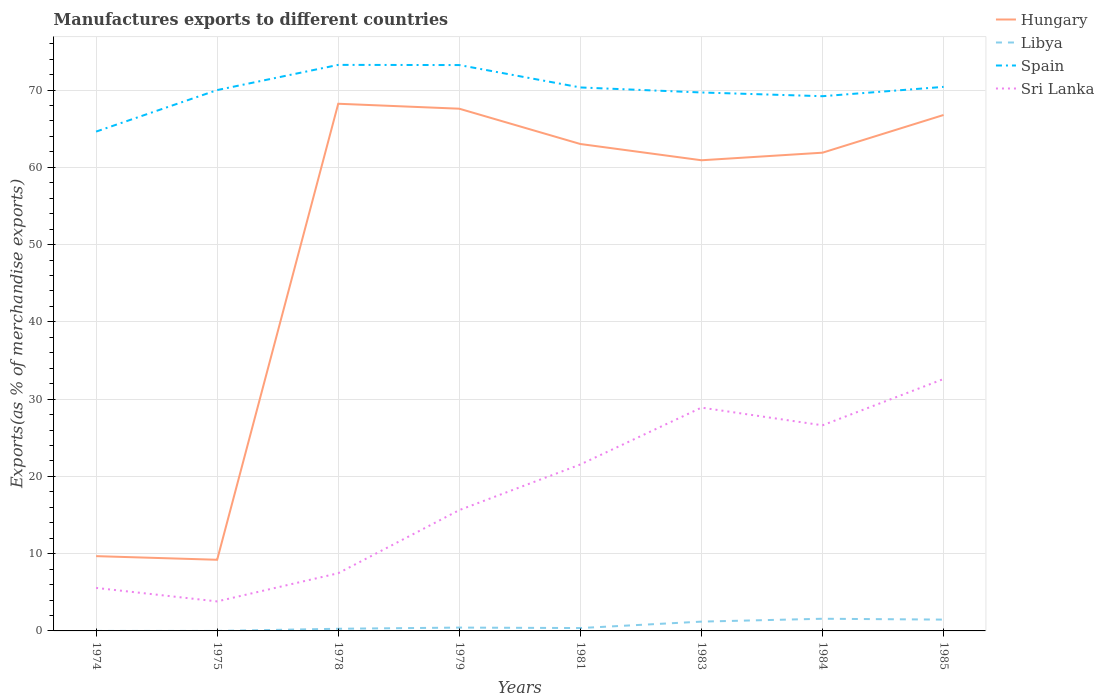How many different coloured lines are there?
Ensure brevity in your answer.  4. Does the line corresponding to Hungary intersect with the line corresponding to Spain?
Your answer should be compact. No. Across all years, what is the maximum percentage of exports to different countries in Spain?
Provide a succinct answer. 64.62. In which year was the percentage of exports to different countries in Hungary maximum?
Give a very brief answer. 1975. What is the total percentage of exports to different countries in Sri Lanka in the graph?
Offer a very short reply. -16.97. What is the difference between the highest and the second highest percentage of exports to different countries in Spain?
Keep it short and to the point. 8.64. Is the percentage of exports to different countries in Libya strictly greater than the percentage of exports to different countries in Hungary over the years?
Your answer should be compact. Yes. What is the difference between two consecutive major ticks on the Y-axis?
Make the answer very short. 10. Does the graph contain grids?
Make the answer very short. Yes. How are the legend labels stacked?
Keep it short and to the point. Vertical. What is the title of the graph?
Provide a succinct answer. Manufactures exports to different countries. What is the label or title of the X-axis?
Your response must be concise. Years. What is the label or title of the Y-axis?
Your response must be concise. Exports(as % of merchandise exports). What is the Exports(as % of merchandise exports) in Hungary in 1974?
Your response must be concise. 9.68. What is the Exports(as % of merchandise exports) of Libya in 1974?
Ensure brevity in your answer.  3.148296593577001e-5. What is the Exports(as % of merchandise exports) of Spain in 1974?
Your response must be concise. 64.62. What is the Exports(as % of merchandise exports) in Sri Lanka in 1974?
Your answer should be very brief. 5.57. What is the Exports(as % of merchandise exports) in Hungary in 1975?
Offer a very short reply. 9.21. What is the Exports(as % of merchandise exports) of Libya in 1975?
Provide a short and direct response. 9.803995570574699e-7. What is the Exports(as % of merchandise exports) of Spain in 1975?
Ensure brevity in your answer.  70. What is the Exports(as % of merchandise exports) of Sri Lanka in 1975?
Keep it short and to the point. 3.82. What is the Exports(as % of merchandise exports) of Hungary in 1978?
Make the answer very short. 68.23. What is the Exports(as % of merchandise exports) of Libya in 1978?
Offer a terse response. 0.28. What is the Exports(as % of merchandise exports) in Spain in 1978?
Offer a terse response. 73.26. What is the Exports(as % of merchandise exports) in Sri Lanka in 1978?
Make the answer very short. 7.47. What is the Exports(as % of merchandise exports) of Hungary in 1979?
Make the answer very short. 67.59. What is the Exports(as % of merchandise exports) in Libya in 1979?
Offer a terse response. 0.43. What is the Exports(as % of merchandise exports) in Spain in 1979?
Offer a terse response. 73.23. What is the Exports(as % of merchandise exports) of Sri Lanka in 1979?
Your answer should be very brief. 15.64. What is the Exports(as % of merchandise exports) of Hungary in 1981?
Provide a succinct answer. 63.02. What is the Exports(as % of merchandise exports) of Libya in 1981?
Offer a terse response. 0.37. What is the Exports(as % of merchandise exports) of Spain in 1981?
Your response must be concise. 70.34. What is the Exports(as % of merchandise exports) in Sri Lanka in 1981?
Make the answer very short. 21.54. What is the Exports(as % of merchandise exports) in Hungary in 1983?
Your response must be concise. 60.91. What is the Exports(as % of merchandise exports) in Libya in 1983?
Give a very brief answer. 1.2. What is the Exports(as % of merchandise exports) in Spain in 1983?
Make the answer very short. 69.69. What is the Exports(as % of merchandise exports) of Sri Lanka in 1983?
Give a very brief answer. 28.9. What is the Exports(as % of merchandise exports) of Hungary in 1984?
Give a very brief answer. 61.89. What is the Exports(as % of merchandise exports) in Libya in 1984?
Make the answer very short. 1.58. What is the Exports(as % of merchandise exports) of Spain in 1984?
Give a very brief answer. 69.2. What is the Exports(as % of merchandise exports) in Sri Lanka in 1984?
Provide a short and direct response. 26.61. What is the Exports(as % of merchandise exports) in Hungary in 1985?
Offer a terse response. 66.77. What is the Exports(as % of merchandise exports) of Libya in 1985?
Provide a succinct answer. 1.46. What is the Exports(as % of merchandise exports) of Spain in 1985?
Make the answer very short. 70.41. What is the Exports(as % of merchandise exports) of Sri Lanka in 1985?
Keep it short and to the point. 32.6. Across all years, what is the maximum Exports(as % of merchandise exports) in Hungary?
Provide a succinct answer. 68.23. Across all years, what is the maximum Exports(as % of merchandise exports) in Libya?
Offer a terse response. 1.58. Across all years, what is the maximum Exports(as % of merchandise exports) of Spain?
Provide a short and direct response. 73.26. Across all years, what is the maximum Exports(as % of merchandise exports) in Sri Lanka?
Provide a succinct answer. 32.6. Across all years, what is the minimum Exports(as % of merchandise exports) in Hungary?
Offer a very short reply. 9.21. Across all years, what is the minimum Exports(as % of merchandise exports) in Libya?
Give a very brief answer. 9.803995570574699e-7. Across all years, what is the minimum Exports(as % of merchandise exports) in Spain?
Offer a very short reply. 64.62. Across all years, what is the minimum Exports(as % of merchandise exports) of Sri Lanka?
Your answer should be compact. 3.82. What is the total Exports(as % of merchandise exports) in Hungary in the graph?
Give a very brief answer. 407.3. What is the total Exports(as % of merchandise exports) in Libya in the graph?
Offer a very short reply. 5.33. What is the total Exports(as % of merchandise exports) in Spain in the graph?
Provide a short and direct response. 560.75. What is the total Exports(as % of merchandise exports) of Sri Lanka in the graph?
Your answer should be very brief. 142.15. What is the difference between the Exports(as % of merchandise exports) in Hungary in 1974 and that in 1975?
Offer a terse response. 0.47. What is the difference between the Exports(as % of merchandise exports) of Libya in 1974 and that in 1975?
Give a very brief answer. 0. What is the difference between the Exports(as % of merchandise exports) in Spain in 1974 and that in 1975?
Offer a very short reply. -5.37. What is the difference between the Exports(as % of merchandise exports) in Sri Lanka in 1974 and that in 1975?
Provide a short and direct response. 1.75. What is the difference between the Exports(as % of merchandise exports) of Hungary in 1974 and that in 1978?
Your answer should be very brief. -58.55. What is the difference between the Exports(as % of merchandise exports) in Libya in 1974 and that in 1978?
Make the answer very short. -0.28. What is the difference between the Exports(as % of merchandise exports) of Spain in 1974 and that in 1978?
Provide a succinct answer. -8.64. What is the difference between the Exports(as % of merchandise exports) of Hungary in 1974 and that in 1979?
Your answer should be very brief. -57.91. What is the difference between the Exports(as % of merchandise exports) in Libya in 1974 and that in 1979?
Provide a succinct answer. -0.43. What is the difference between the Exports(as % of merchandise exports) of Spain in 1974 and that in 1979?
Make the answer very short. -8.61. What is the difference between the Exports(as % of merchandise exports) of Sri Lanka in 1974 and that in 1979?
Provide a succinct answer. -10.07. What is the difference between the Exports(as % of merchandise exports) of Hungary in 1974 and that in 1981?
Keep it short and to the point. -53.34. What is the difference between the Exports(as % of merchandise exports) in Libya in 1974 and that in 1981?
Make the answer very short. -0.37. What is the difference between the Exports(as % of merchandise exports) of Spain in 1974 and that in 1981?
Offer a terse response. -5.71. What is the difference between the Exports(as % of merchandise exports) in Sri Lanka in 1974 and that in 1981?
Make the answer very short. -15.98. What is the difference between the Exports(as % of merchandise exports) of Hungary in 1974 and that in 1983?
Your answer should be very brief. -51.23. What is the difference between the Exports(as % of merchandise exports) in Libya in 1974 and that in 1983?
Make the answer very short. -1.2. What is the difference between the Exports(as % of merchandise exports) of Spain in 1974 and that in 1983?
Offer a terse response. -5.06. What is the difference between the Exports(as % of merchandise exports) in Sri Lanka in 1974 and that in 1983?
Give a very brief answer. -23.33. What is the difference between the Exports(as % of merchandise exports) in Hungary in 1974 and that in 1984?
Ensure brevity in your answer.  -52.22. What is the difference between the Exports(as % of merchandise exports) in Libya in 1974 and that in 1984?
Provide a short and direct response. -1.58. What is the difference between the Exports(as % of merchandise exports) in Spain in 1974 and that in 1984?
Your answer should be compact. -4.58. What is the difference between the Exports(as % of merchandise exports) in Sri Lanka in 1974 and that in 1984?
Ensure brevity in your answer.  -21.04. What is the difference between the Exports(as % of merchandise exports) in Hungary in 1974 and that in 1985?
Your answer should be very brief. -57.1. What is the difference between the Exports(as % of merchandise exports) in Libya in 1974 and that in 1985?
Your answer should be compact. -1.46. What is the difference between the Exports(as % of merchandise exports) of Spain in 1974 and that in 1985?
Offer a terse response. -5.79. What is the difference between the Exports(as % of merchandise exports) in Sri Lanka in 1974 and that in 1985?
Your answer should be compact. -27.04. What is the difference between the Exports(as % of merchandise exports) of Hungary in 1975 and that in 1978?
Give a very brief answer. -59.02. What is the difference between the Exports(as % of merchandise exports) of Libya in 1975 and that in 1978?
Give a very brief answer. -0.28. What is the difference between the Exports(as % of merchandise exports) of Spain in 1975 and that in 1978?
Keep it short and to the point. -3.26. What is the difference between the Exports(as % of merchandise exports) in Sri Lanka in 1975 and that in 1978?
Ensure brevity in your answer.  -3.65. What is the difference between the Exports(as % of merchandise exports) of Hungary in 1975 and that in 1979?
Make the answer very short. -58.38. What is the difference between the Exports(as % of merchandise exports) in Libya in 1975 and that in 1979?
Keep it short and to the point. -0.43. What is the difference between the Exports(as % of merchandise exports) of Spain in 1975 and that in 1979?
Ensure brevity in your answer.  -3.24. What is the difference between the Exports(as % of merchandise exports) of Sri Lanka in 1975 and that in 1979?
Your response must be concise. -11.82. What is the difference between the Exports(as % of merchandise exports) in Hungary in 1975 and that in 1981?
Ensure brevity in your answer.  -53.81. What is the difference between the Exports(as % of merchandise exports) in Libya in 1975 and that in 1981?
Your response must be concise. -0.37. What is the difference between the Exports(as % of merchandise exports) in Spain in 1975 and that in 1981?
Provide a short and direct response. -0.34. What is the difference between the Exports(as % of merchandise exports) of Sri Lanka in 1975 and that in 1981?
Offer a terse response. -17.72. What is the difference between the Exports(as % of merchandise exports) in Hungary in 1975 and that in 1983?
Provide a succinct answer. -51.7. What is the difference between the Exports(as % of merchandise exports) of Libya in 1975 and that in 1983?
Your answer should be compact. -1.2. What is the difference between the Exports(as % of merchandise exports) in Spain in 1975 and that in 1983?
Provide a short and direct response. 0.31. What is the difference between the Exports(as % of merchandise exports) of Sri Lanka in 1975 and that in 1983?
Ensure brevity in your answer.  -25.08. What is the difference between the Exports(as % of merchandise exports) of Hungary in 1975 and that in 1984?
Provide a succinct answer. -52.69. What is the difference between the Exports(as % of merchandise exports) of Libya in 1975 and that in 1984?
Make the answer very short. -1.58. What is the difference between the Exports(as % of merchandise exports) in Spain in 1975 and that in 1984?
Provide a short and direct response. 0.79. What is the difference between the Exports(as % of merchandise exports) in Sri Lanka in 1975 and that in 1984?
Provide a succinct answer. -22.79. What is the difference between the Exports(as % of merchandise exports) in Hungary in 1975 and that in 1985?
Give a very brief answer. -57.56. What is the difference between the Exports(as % of merchandise exports) of Libya in 1975 and that in 1985?
Make the answer very short. -1.46. What is the difference between the Exports(as % of merchandise exports) in Spain in 1975 and that in 1985?
Offer a very short reply. -0.41. What is the difference between the Exports(as % of merchandise exports) of Sri Lanka in 1975 and that in 1985?
Keep it short and to the point. -28.78. What is the difference between the Exports(as % of merchandise exports) of Hungary in 1978 and that in 1979?
Your answer should be compact. 0.64. What is the difference between the Exports(as % of merchandise exports) of Libya in 1978 and that in 1979?
Give a very brief answer. -0.15. What is the difference between the Exports(as % of merchandise exports) in Spain in 1978 and that in 1979?
Ensure brevity in your answer.  0.02. What is the difference between the Exports(as % of merchandise exports) in Sri Lanka in 1978 and that in 1979?
Ensure brevity in your answer.  -8.17. What is the difference between the Exports(as % of merchandise exports) in Hungary in 1978 and that in 1981?
Provide a succinct answer. 5.21. What is the difference between the Exports(as % of merchandise exports) in Libya in 1978 and that in 1981?
Your answer should be compact. -0.09. What is the difference between the Exports(as % of merchandise exports) of Spain in 1978 and that in 1981?
Give a very brief answer. 2.92. What is the difference between the Exports(as % of merchandise exports) of Sri Lanka in 1978 and that in 1981?
Make the answer very short. -14.08. What is the difference between the Exports(as % of merchandise exports) in Hungary in 1978 and that in 1983?
Offer a very short reply. 7.31. What is the difference between the Exports(as % of merchandise exports) in Libya in 1978 and that in 1983?
Provide a short and direct response. -0.92. What is the difference between the Exports(as % of merchandise exports) of Spain in 1978 and that in 1983?
Your answer should be very brief. 3.57. What is the difference between the Exports(as % of merchandise exports) in Sri Lanka in 1978 and that in 1983?
Offer a very short reply. -21.43. What is the difference between the Exports(as % of merchandise exports) of Hungary in 1978 and that in 1984?
Provide a short and direct response. 6.33. What is the difference between the Exports(as % of merchandise exports) in Libya in 1978 and that in 1984?
Keep it short and to the point. -1.3. What is the difference between the Exports(as % of merchandise exports) of Spain in 1978 and that in 1984?
Offer a very short reply. 4.05. What is the difference between the Exports(as % of merchandise exports) in Sri Lanka in 1978 and that in 1984?
Keep it short and to the point. -19.14. What is the difference between the Exports(as % of merchandise exports) of Hungary in 1978 and that in 1985?
Ensure brevity in your answer.  1.45. What is the difference between the Exports(as % of merchandise exports) of Libya in 1978 and that in 1985?
Make the answer very short. -1.19. What is the difference between the Exports(as % of merchandise exports) in Spain in 1978 and that in 1985?
Provide a short and direct response. 2.85. What is the difference between the Exports(as % of merchandise exports) in Sri Lanka in 1978 and that in 1985?
Your response must be concise. -25.14. What is the difference between the Exports(as % of merchandise exports) in Hungary in 1979 and that in 1981?
Offer a very short reply. 4.57. What is the difference between the Exports(as % of merchandise exports) of Libya in 1979 and that in 1981?
Offer a terse response. 0.06. What is the difference between the Exports(as % of merchandise exports) in Spain in 1979 and that in 1981?
Give a very brief answer. 2.9. What is the difference between the Exports(as % of merchandise exports) in Sri Lanka in 1979 and that in 1981?
Offer a very short reply. -5.9. What is the difference between the Exports(as % of merchandise exports) of Hungary in 1979 and that in 1983?
Offer a terse response. 6.67. What is the difference between the Exports(as % of merchandise exports) in Libya in 1979 and that in 1983?
Provide a succinct answer. -0.77. What is the difference between the Exports(as % of merchandise exports) of Spain in 1979 and that in 1983?
Give a very brief answer. 3.55. What is the difference between the Exports(as % of merchandise exports) in Sri Lanka in 1979 and that in 1983?
Offer a terse response. -13.26. What is the difference between the Exports(as % of merchandise exports) in Hungary in 1979 and that in 1984?
Keep it short and to the point. 5.69. What is the difference between the Exports(as % of merchandise exports) of Libya in 1979 and that in 1984?
Make the answer very short. -1.14. What is the difference between the Exports(as % of merchandise exports) of Spain in 1979 and that in 1984?
Give a very brief answer. 4.03. What is the difference between the Exports(as % of merchandise exports) of Sri Lanka in 1979 and that in 1984?
Make the answer very short. -10.97. What is the difference between the Exports(as % of merchandise exports) of Hungary in 1979 and that in 1985?
Provide a succinct answer. 0.81. What is the difference between the Exports(as % of merchandise exports) in Libya in 1979 and that in 1985?
Provide a succinct answer. -1.03. What is the difference between the Exports(as % of merchandise exports) of Spain in 1979 and that in 1985?
Your answer should be very brief. 2.82. What is the difference between the Exports(as % of merchandise exports) of Sri Lanka in 1979 and that in 1985?
Keep it short and to the point. -16.97. What is the difference between the Exports(as % of merchandise exports) in Hungary in 1981 and that in 1983?
Your answer should be compact. 2.1. What is the difference between the Exports(as % of merchandise exports) in Libya in 1981 and that in 1983?
Provide a short and direct response. -0.83. What is the difference between the Exports(as % of merchandise exports) of Spain in 1981 and that in 1983?
Ensure brevity in your answer.  0.65. What is the difference between the Exports(as % of merchandise exports) of Sri Lanka in 1981 and that in 1983?
Your answer should be very brief. -7.36. What is the difference between the Exports(as % of merchandise exports) of Hungary in 1981 and that in 1984?
Give a very brief answer. 1.12. What is the difference between the Exports(as % of merchandise exports) in Libya in 1981 and that in 1984?
Ensure brevity in your answer.  -1.2. What is the difference between the Exports(as % of merchandise exports) in Spain in 1981 and that in 1984?
Provide a succinct answer. 1.13. What is the difference between the Exports(as % of merchandise exports) in Sri Lanka in 1981 and that in 1984?
Your response must be concise. -5.07. What is the difference between the Exports(as % of merchandise exports) of Hungary in 1981 and that in 1985?
Offer a terse response. -3.76. What is the difference between the Exports(as % of merchandise exports) in Libya in 1981 and that in 1985?
Keep it short and to the point. -1.09. What is the difference between the Exports(as % of merchandise exports) in Spain in 1981 and that in 1985?
Offer a very short reply. -0.07. What is the difference between the Exports(as % of merchandise exports) of Sri Lanka in 1981 and that in 1985?
Offer a terse response. -11.06. What is the difference between the Exports(as % of merchandise exports) of Hungary in 1983 and that in 1984?
Ensure brevity in your answer.  -0.98. What is the difference between the Exports(as % of merchandise exports) in Libya in 1983 and that in 1984?
Your answer should be compact. -0.37. What is the difference between the Exports(as % of merchandise exports) of Spain in 1983 and that in 1984?
Offer a terse response. 0.48. What is the difference between the Exports(as % of merchandise exports) of Sri Lanka in 1983 and that in 1984?
Your answer should be very brief. 2.29. What is the difference between the Exports(as % of merchandise exports) in Hungary in 1983 and that in 1985?
Offer a very short reply. -5.86. What is the difference between the Exports(as % of merchandise exports) in Libya in 1983 and that in 1985?
Provide a short and direct response. -0.26. What is the difference between the Exports(as % of merchandise exports) of Spain in 1983 and that in 1985?
Your answer should be very brief. -0.72. What is the difference between the Exports(as % of merchandise exports) of Sri Lanka in 1983 and that in 1985?
Your answer should be compact. -3.7. What is the difference between the Exports(as % of merchandise exports) of Hungary in 1984 and that in 1985?
Keep it short and to the point. -4.88. What is the difference between the Exports(as % of merchandise exports) of Libya in 1984 and that in 1985?
Give a very brief answer. 0.11. What is the difference between the Exports(as % of merchandise exports) in Spain in 1984 and that in 1985?
Offer a terse response. -1.21. What is the difference between the Exports(as % of merchandise exports) in Sri Lanka in 1984 and that in 1985?
Ensure brevity in your answer.  -5.99. What is the difference between the Exports(as % of merchandise exports) in Hungary in 1974 and the Exports(as % of merchandise exports) in Libya in 1975?
Your response must be concise. 9.68. What is the difference between the Exports(as % of merchandise exports) of Hungary in 1974 and the Exports(as % of merchandise exports) of Spain in 1975?
Provide a short and direct response. -60.32. What is the difference between the Exports(as % of merchandise exports) in Hungary in 1974 and the Exports(as % of merchandise exports) in Sri Lanka in 1975?
Keep it short and to the point. 5.86. What is the difference between the Exports(as % of merchandise exports) of Libya in 1974 and the Exports(as % of merchandise exports) of Spain in 1975?
Make the answer very short. -70. What is the difference between the Exports(as % of merchandise exports) of Libya in 1974 and the Exports(as % of merchandise exports) of Sri Lanka in 1975?
Offer a terse response. -3.82. What is the difference between the Exports(as % of merchandise exports) of Spain in 1974 and the Exports(as % of merchandise exports) of Sri Lanka in 1975?
Offer a very short reply. 60.8. What is the difference between the Exports(as % of merchandise exports) of Hungary in 1974 and the Exports(as % of merchandise exports) of Libya in 1978?
Offer a very short reply. 9.4. What is the difference between the Exports(as % of merchandise exports) of Hungary in 1974 and the Exports(as % of merchandise exports) of Spain in 1978?
Offer a very short reply. -63.58. What is the difference between the Exports(as % of merchandise exports) in Hungary in 1974 and the Exports(as % of merchandise exports) in Sri Lanka in 1978?
Provide a short and direct response. 2.21. What is the difference between the Exports(as % of merchandise exports) of Libya in 1974 and the Exports(as % of merchandise exports) of Spain in 1978?
Your answer should be compact. -73.26. What is the difference between the Exports(as % of merchandise exports) of Libya in 1974 and the Exports(as % of merchandise exports) of Sri Lanka in 1978?
Offer a very short reply. -7.47. What is the difference between the Exports(as % of merchandise exports) of Spain in 1974 and the Exports(as % of merchandise exports) of Sri Lanka in 1978?
Make the answer very short. 57.16. What is the difference between the Exports(as % of merchandise exports) of Hungary in 1974 and the Exports(as % of merchandise exports) of Libya in 1979?
Keep it short and to the point. 9.25. What is the difference between the Exports(as % of merchandise exports) of Hungary in 1974 and the Exports(as % of merchandise exports) of Spain in 1979?
Give a very brief answer. -63.56. What is the difference between the Exports(as % of merchandise exports) of Hungary in 1974 and the Exports(as % of merchandise exports) of Sri Lanka in 1979?
Keep it short and to the point. -5.96. What is the difference between the Exports(as % of merchandise exports) in Libya in 1974 and the Exports(as % of merchandise exports) in Spain in 1979?
Your response must be concise. -73.23. What is the difference between the Exports(as % of merchandise exports) of Libya in 1974 and the Exports(as % of merchandise exports) of Sri Lanka in 1979?
Ensure brevity in your answer.  -15.64. What is the difference between the Exports(as % of merchandise exports) of Spain in 1974 and the Exports(as % of merchandise exports) of Sri Lanka in 1979?
Offer a terse response. 48.98. What is the difference between the Exports(as % of merchandise exports) in Hungary in 1974 and the Exports(as % of merchandise exports) in Libya in 1981?
Offer a very short reply. 9.31. What is the difference between the Exports(as % of merchandise exports) of Hungary in 1974 and the Exports(as % of merchandise exports) of Spain in 1981?
Ensure brevity in your answer.  -60.66. What is the difference between the Exports(as % of merchandise exports) in Hungary in 1974 and the Exports(as % of merchandise exports) in Sri Lanka in 1981?
Your answer should be compact. -11.86. What is the difference between the Exports(as % of merchandise exports) of Libya in 1974 and the Exports(as % of merchandise exports) of Spain in 1981?
Your answer should be very brief. -70.34. What is the difference between the Exports(as % of merchandise exports) of Libya in 1974 and the Exports(as % of merchandise exports) of Sri Lanka in 1981?
Your answer should be compact. -21.54. What is the difference between the Exports(as % of merchandise exports) of Spain in 1974 and the Exports(as % of merchandise exports) of Sri Lanka in 1981?
Keep it short and to the point. 43.08. What is the difference between the Exports(as % of merchandise exports) of Hungary in 1974 and the Exports(as % of merchandise exports) of Libya in 1983?
Provide a succinct answer. 8.48. What is the difference between the Exports(as % of merchandise exports) in Hungary in 1974 and the Exports(as % of merchandise exports) in Spain in 1983?
Provide a succinct answer. -60.01. What is the difference between the Exports(as % of merchandise exports) of Hungary in 1974 and the Exports(as % of merchandise exports) of Sri Lanka in 1983?
Your answer should be compact. -19.22. What is the difference between the Exports(as % of merchandise exports) of Libya in 1974 and the Exports(as % of merchandise exports) of Spain in 1983?
Ensure brevity in your answer.  -69.69. What is the difference between the Exports(as % of merchandise exports) in Libya in 1974 and the Exports(as % of merchandise exports) in Sri Lanka in 1983?
Give a very brief answer. -28.9. What is the difference between the Exports(as % of merchandise exports) of Spain in 1974 and the Exports(as % of merchandise exports) of Sri Lanka in 1983?
Offer a terse response. 35.72. What is the difference between the Exports(as % of merchandise exports) in Hungary in 1974 and the Exports(as % of merchandise exports) in Libya in 1984?
Keep it short and to the point. 8.1. What is the difference between the Exports(as % of merchandise exports) of Hungary in 1974 and the Exports(as % of merchandise exports) of Spain in 1984?
Offer a terse response. -59.53. What is the difference between the Exports(as % of merchandise exports) in Hungary in 1974 and the Exports(as % of merchandise exports) in Sri Lanka in 1984?
Provide a succinct answer. -16.93. What is the difference between the Exports(as % of merchandise exports) in Libya in 1974 and the Exports(as % of merchandise exports) in Spain in 1984?
Offer a very short reply. -69.2. What is the difference between the Exports(as % of merchandise exports) in Libya in 1974 and the Exports(as % of merchandise exports) in Sri Lanka in 1984?
Your response must be concise. -26.61. What is the difference between the Exports(as % of merchandise exports) of Spain in 1974 and the Exports(as % of merchandise exports) of Sri Lanka in 1984?
Give a very brief answer. 38.01. What is the difference between the Exports(as % of merchandise exports) in Hungary in 1974 and the Exports(as % of merchandise exports) in Libya in 1985?
Provide a short and direct response. 8.21. What is the difference between the Exports(as % of merchandise exports) of Hungary in 1974 and the Exports(as % of merchandise exports) of Spain in 1985?
Offer a terse response. -60.73. What is the difference between the Exports(as % of merchandise exports) of Hungary in 1974 and the Exports(as % of merchandise exports) of Sri Lanka in 1985?
Your response must be concise. -22.93. What is the difference between the Exports(as % of merchandise exports) in Libya in 1974 and the Exports(as % of merchandise exports) in Spain in 1985?
Your response must be concise. -70.41. What is the difference between the Exports(as % of merchandise exports) in Libya in 1974 and the Exports(as % of merchandise exports) in Sri Lanka in 1985?
Keep it short and to the point. -32.6. What is the difference between the Exports(as % of merchandise exports) in Spain in 1974 and the Exports(as % of merchandise exports) in Sri Lanka in 1985?
Keep it short and to the point. 32.02. What is the difference between the Exports(as % of merchandise exports) in Hungary in 1975 and the Exports(as % of merchandise exports) in Libya in 1978?
Offer a very short reply. 8.93. What is the difference between the Exports(as % of merchandise exports) of Hungary in 1975 and the Exports(as % of merchandise exports) of Spain in 1978?
Give a very brief answer. -64.05. What is the difference between the Exports(as % of merchandise exports) in Hungary in 1975 and the Exports(as % of merchandise exports) in Sri Lanka in 1978?
Offer a very short reply. 1.74. What is the difference between the Exports(as % of merchandise exports) of Libya in 1975 and the Exports(as % of merchandise exports) of Spain in 1978?
Your response must be concise. -73.26. What is the difference between the Exports(as % of merchandise exports) in Libya in 1975 and the Exports(as % of merchandise exports) in Sri Lanka in 1978?
Your answer should be compact. -7.47. What is the difference between the Exports(as % of merchandise exports) in Spain in 1975 and the Exports(as % of merchandise exports) in Sri Lanka in 1978?
Provide a short and direct response. 62.53. What is the difference between the Exports(as % of merchandise exports) of Hungary in 1975 and the Exports(as % of merchandise exports) of Libya in 1979?
Ensure brevity in your answer.  8.78. What is the difference between the Exports(as % of merchandise exports) in Hungary in 1975 and the Exports(as % of merchandise exports) in Spain in 1979?
Your answer should be very brief. -64.03. What is the difference between the Exports(as % of merchandise exports) of Hungary in 1975 and the Exports(as % of merchandise exports) of Sri Lanka in 1979?
Provide a short and direct response. -6.43. What is the difference between the Exports(as % of merchandise exports) in Libya in 1975 and the Exports(as % of merchandise exports) in Spain in 1979?
Your response must be concise. -73.23. What is the difference between the Exports(as % of merchandise exports) in Libya in 1975 and the Exports(as % of merchandise exports) in Sri Lanka in 1979?
Offer a very short reply. -15.64. What is the difference between the Exports(as % of merchandise exports) of Spain in 1975 and the Exports(as % of merchandise exports) of Sri Lanka in 1979?
Give a very brief answer. 54.36. What is the difference between the Exports(as % of merchandise exports) in Hungary in 1975 and the Exports(as % of merchandise exports) in Libya in 1981?
Ensure brevity in your answer.  8.84. What is the difference between the Exports(as % of merchandise exports) of Hungary in 1975 and the Exports(as % of merchandise exports) of Spain in 1981?
Provide a short and direct response. -61.13. What is the difference between the Exports(as % of merchandise exports) of Hungary in 1975 and the Exports(as % of merchandise exports) of Sri Lanka in 1981?
Your answer should be compact. -12.33. What is the difference between the Exports(as % of merchandise exports) in Libya in 1975 and the Exports(as % of merchandise exports) in Spain in 1981?
Your answer should be compact. -70.34. What is the difference between the Exports(as % of merchandise exports) of Libya in 1975 and the Exports(as % of merchandise exports) of Sri Lanka in 1981?
Keep it short and to the point. -21.54. What is the difference between the Exports(as % of merchandise exports) of Spain in 1975 and the Exports(as % of merchandise exports) of Sri Lanka in 1981?
Make the answer very short. 48.45. What is the difference between the Exports(as % of merchandise exports) in Hungary in 1975 and the Exports(as % of merchandise exports) in Libya in 1983?
Your response must be concise. 8.01. What is the difference between the Exports(as % of merchandise exports) in Hungary in 1975 and the Exports(as % of merchandise exports) in Spain in 1983?
Give a very brief answer. -60.48. What is the difference between the Exports(as % of merchandise exports) of Hungary in 1975 and the Exports(as % of merchandise exports) of Sri Lanka in 1983?
Provide a short and direct response. -19.69. What is the difference between the Exports(as % of merchandise exports) in Libya in 1975 and the Exports(as % of merchandise exports) in Spain in 1983?
Ensure brevity in your answer.  -69.69. What is the difference between the Exports(as % of merchandise exports) of Libya in 1975 and the Exports(as % of merchandise exports) of Sri Lanka in 1983?
Provide a short and direct response. -28.9. What is the difference between the Exports(as % of merchandise exports) in Spain in 1975 and the Exports(as % of merchandise exports) in Sri Lanka in 1983?
Your answer should be compact. 41.1. What is the difference between the Exports(as % of merchandise exports) in Hungary in 1975 and the Exports(as % of merchandise exports) in Libya in 1984?
Ensure brevity in your answer.  7.63. What is the difference between the Exports(as % of merchandise exports) of Hungary in 1975 and the Exports(as % of merchandise exports) of Spain in 1984?
Offer a very short reply. -60. What is the difference between the Exports(as % of merchandise exports) of Hungary in 1975 and the Exports(as % of merchandise exports) of Sri Lanka in 1984?
Your answer should be compact. -17.4. What is the difference between the Exports(as % of merchandise exports) of Libya in 1975 and the Exports(as % of merchandise exports) of Spain in 1984?
Your response must be concise. -69.2. What is the difference between the Exports(as % of merchandise exports) in Libya in 1975 and the Exports(as % of merchandise exports) in Sri Lanka in 1984?
Offer a very short reply. -26.61. What is the difference between the Exports(as % of merchandise exports) in Spain in 1975 and the Exports(as % of merchandise exports) in Sri Lanka in 1984?
Provide a succinct answer. 43.38. What is the difference between the Exports(as % of merchandise exports) in Hungary in 1975 and the Exports(as % of merchandise exports) in Libya in 1985?
Provide a short and direct response. 7.74. What is the difference between the Exports(as % of merchandise exports) of Hungary in 1975 and the Exports(as % of merchandise exports) of Spain in 1985?
Your response must be concise. -61.2. What is the difference between the Exports(as % of merchandise exports) of Hungary in 1975 and the Exports(as % of merchandise exports) of Sri Lanka in 1985?
Your answer should be very brief. -23.4. What is the difference between the Exports(as % of merchandise exports) in Libya in 1975 and the Exports(as % of merchandise exports) in Spain in 1985?
Offer a terse response. -70.41. What is the difference between the Exports(as % of merchandise exports) of Libya in 1975 and the Exports(as % of merchandise exports) of Sri Lanka in 1985?
Your response must be concise. -32.6. What is the difference between the Exports(as % of merchandise exports) of Spain in 1975 and the Exports(as % of merchandise exports) of Sri Lanka in 1985?
Your answer should be very brief. 37.39. What is the difference between the Exports(as % of merchandise exports) of Hungary in 1978 and the Exports(as % of merchandise exports) of Libya in 1979?
Ensure brevity in your answer.  67.8. What is the difference between the Exports(as % of merchandise exports) of Hungary in 1978 and the Exports(as % of merchandise exports) of Spain in 1979?
Your answer should be very brief. -5.01. What is the difference between the Exports(as % of merchandise exports) of Hungary in 1978 and the Exports(as % of merchandise exports) of Sri Lanka in 1979?
Offer a very short reply. 52.59. What is the difference between the Exports(as % of merchandise exports) in Libya in 1978 and the Exports(as % of merchandise exports) in Spain in 1979?
Make the answer very short. -72.95. What is the difference between the Exports(as % of merchandise exports) in Libya in 1978 and the Exports(as % of merchandise exports) in Sri Lanka in 1979?
Provide a short and direct response. -15.36. What is the difference between the Exports(as % of merchandise exports) in Spain in 1978 and the Exports(as % of merchandise exports) in Sri Lanka in 1979?
Your answer should be compact. 57.62. What is the difference between the Exports(as % of merchandise exports) of Hungary in 1978 and the Exports(as % of merchandise exports) of Libya in 1981?
Offer a terse response. 67.86. What is the difference between the Exports(as % of merchandise exports) in Hungary in 1978 and the Exports(as % of merchandise exports) in Spain in 1981?
Give a very brief answer. -2.11. What is the difference between the Exports(as % of merchandise exports) in Hungary in 1978 and the Exports(as % of merchandise exports) in Sri Lanka in 1981?
Keep it short and to the point. 46.69. What is the difference between the Exports(as % of merchandise exports) in Libya in 1978 and the Exports(as % of merchandise exports) in Spain in 1981?
Your response must be concise. -70.06. What is the difference between the Exports(as % of merchandise exports) of Libya in 1978 and the Exports(as % of merchandise exports) of Sri Lanka in 1981?
Keep it short and to the point. -21.26. What is the difference between the Exports(as % of merchandise exports) of Spain in 1978 and the Exports(as % of merchandise exports) of Sri Lanka in 1981?
Provide a short and direct response. 51.72. What is the difference between the Exports(as % of merchandise exports) in Hungary in 1978 and the Exports(as % of merchandise exports) in Libya in 1983?
Give a very brief answer. 67.02. What is the difference between the Exports(as % of merchandise exports) of Hungary in 1978 and the Exports(as % of merchandise exports) of Spain in 1983?
Make the answer very short. -1.46. What is the difference between the Exports(as % of merchandise exports) in Hungary in 1978 and the Exports(as % of merchandise exports) in Sri Lanka in 1983?
Ensure brevity in your answer.  39.33. What is the difference between the Exports(as % of merchandise exports) in Libya in 1978 and the Exports(as % of merchandise exports) in Spain in 1983?
Your response must be concise. -69.41. What is the difference between the Exports(as % of merchandise exports) in Libya in 1978 and the Exports(as % of merchandise exports) in Sri Lanka in 1983?
Provide a short and direct response. -28.62. What is the difference between the Exports(as % of merchandise exports) of Spain in 1978 and the Exports(as % of merchandise exports) of Sri Lanka in 1983?
Offer a terse response. 44.36. What is the difference between the Exports(as % of merchandise exports) in Hungary in 1978 and the Exports(as % of merchandise exports) in Libya in 1984?
Provide a succinct answer. 66.65. What is the difference between the Exports(as % of merchandise exports) in Hungary in 1978 and the Exports(as % of merchandise exports) in Spain in 1984?
Make the answer very short. -0.98. What is the difference between the Exports(as % of merchandise exports) in Hungary in 1978 and the Exports(as % of merchandise exports) in Sri Lanka in 1984?
Ensure brevity in your answer.  41.62. What is the difference between the Exports(as % of merchandise exports) of Libya in 1978 and the Exports(as % of merchandise exports) of Spain in 1984?
Your answer should be very brief. -68.92. What is the difference between the Exports(as % of merchandise exports) in Libya in 1978 and the Exports(as % of merchandise exports) in Sri Lanka in 1984?
Provide a short and direct response. -26.33. What is the difference between the Exports(as % of merchandise exports) in Spain in 1978 and the Exports(as % of merchandise exports) in Sri Lanka in 1984?
Provide a short and direct response. 46.65. What is the difference between the Exports(as % of merchandise exports) in Hungary in 1978 and the Exports(as % of merchandise exports) in Libya in 1985?
Offer a very short reply. 66.76. What is the difference between the Exports(as % of merchandise exports) in Hungary in 1978 and the Exports(as % of merchandise exports) in Spain in 1985?
Give a very brief answer. -2.18. What is the difference between the Exports(as % of merchandise exports) in Hungary in 1978 and the Exports(as % of merchandise exports) in Sri Lanka in 1985?
Provide a short and direct response. 35.62. What is the difference between the Exports(as % of merchandise exports) in Libya in 1978 and the Exports(as % of merchandise exports) in Spain in 1985?
Ensure brevity in your answer.  -70.13. What is the difference between the Exports(as % of merchandise exports) in Libya in 1978 and the Exports(as % of merchandise exports) in Sri Lanka in 1985?
Your response must be concise. -32.32. What is the difference between the Exports(as % of merchandise exports) in Spain in 1978 and the Exports(as % of merchandise exports) in Sri Lanka in 1985?
Provide a short and direct response. 40.65. What is the difference between the Exports(as % of merchandise exports) in Hungary in 1979 and the Exports(as % of merchandise exports) in Libya in 1981?
Keep it short and to the point. 67.21. What is the difference between the Exports(as % of merchandise exports) of Hungary in 1979 and the Exports(as % of merchandise exports) of Spain in 1981?
Your answer should be compact. -2.75. What is the difference between the Exports(as % of merchandise exports) of Hungary in 1979 and the Exports(as % of merchandise exports) of Sri Lanka in 1981?
Your answer should be compact. 46.04. What is the difference between the Exports(as % of merchandise exports) in Libya in 1979 and the Exports(as % of merchandise exports) in Spain in 1981?
Give a very brief answer. -69.9. What is the difference between the Exports(as % of merchandise exports) of Libya in 1979 and the Exports(as % of merchandise exports) of Sri Lanka in 1981?
Make the answer very short. -21.11. What is the difference between the Exports(as % of merchandise exports) in Spain in 1979 and the Exports(as % of merchandise exports) in Sri Lanka in 1981?
Offer a very short reply. 51.69. What is the difference between the Exports(as % of merchandise exports) of Hungary in 1979 and the Exports(as % of merchandise exports) of Libya in 1983?
Make the answer very short. 66.38. What is the difference between the Exports(as % of merchandise exports) in Hungary in 1979 and the Exports(as % of merchandise exports) in Spain in 1983?
Offer a terse response. -2.1. What is the difference between the Exports(as % of merchandise exports) in Hungary in 1979 and the Exports(as % of merchandise exports) in Sri Lanka in 1983?
Make the answer very short. 38.69. What is the difference between the Exports(as % of merchandise exports) in Libya in 1979 and the Exports(as % of merchandise exports) in Spain in 1983?
Your answer should be compact. -69.26. What is the difference between the Exports(as % of merchandise exports) of Libya in 1979 and the Exports(as % of merchandise exports) of Sri Lanka in 1983?
Give a very brief answer. -28.47. What is the difference between the Exports(as % of merchandise exports) of Spain in 1979 and the Exports(as % of merchandise exports) of Sri Lanka in 1983?
Keep it short and to the point. 44.33. What is the difference between the Exports(as % of merchandise exports) in Hungary in 1979 and the Exports(as % of merchandise exports) in Libya in 1984?
Offer a terse response. 66.01. What is the difference between the Exports(as % of merchandise exports) of Hungary in 1979 and the Exports(as % of merchandise exports) of Spain in 1984?
Provide a succinct answer. -1.62. What is the difference between the Exports(as % of merchandise exports) of Hungary in 1979 and the Exports(as % of merchandise exports) of Sri Lanka in 1984?
Give a very brief answer. 40.97. What is the difference between the Exports(as % of merchandise exports) in Libya in 1979 and the Exports(as % of merchandise exports) in Spain in 1984?
Offer a terse response. -68.77. What is the difference between the Exports(as % of merchandise exports) in Libya in 1979 and the Exports(as % of merchandise exports) in Sri Lanka in 1984?
Offer a terse response. -26.18. What is the difference between the Exports(as % of merchandise exports) of Spain in 1979 and the Exports(as % of merchandise exports) of Sri Lanka in 1984?
Your response must be concise. 46.62. What is the difference between the Exports(as % of merchandise exports) of Hungary in 1979 and the Exports(as % of merchandise exports) of Libya in 1985?
Make the answer very short. 66.12. What is the difference between the Exports(as % of merchandise exports) of Hungary in 1979 and the Exports(as % of merchandise exports) of Spain in 1985?
Provide a succinct answer. -2.83. What is the difference between the Exports(as % of merchandise exports) in Hungary in 1979 and the Exports(as % of merchandise exports) in Sri Lanka in 1985?
Your response must be concise. 34.98. What is the difference between the Exports(as % of merchandise exports) in Libya in 1979 and the Exports(as % of merchandise exports) in Spain in 1985?
Ensure brevity in your answer.  -69.98. What is the difference between the Exports(as % of merchandise exports) in Libya in 1979 and the Exports(as % of merchandise exports) in Sri Lanka in 1985?
Your response must be concise. -32.17. What is the difference between the Exports(as % of merchandise exports) in Spain in 1979 and the Exports(as % of merchandise exports) in Sri Lanka in 1985?
Make the answer very short. 40.63. What is the difference between the Exports(as % of merchandise exports) in Hungary in 1981 and the Exports(as % of merchandise exports) in Libya in 1983?
Keep it short and to the point. 61.81. What is the difference between the Exports(as % of merchandise exports) in Hungary in 1981 and the Exports(as % of merchandise exports) in Spain in 1983?
Offer a very short reply. -6.67. What is the difference between the Exports(as % of merchandise exports) of Hungary in 1981 and the Exports(as % of merchandise exports) of Sri Lanka in 1983?
Your answer should be very brief. 34.12. What is the difference between the Exports(as % of merchandise exports) of Libya in 1981 and the Exports(as % of merchandise exports) of Spain in 1983?
Provide a short and direct response. -69.32. What is the difference between the Exports(as % of merchandise exports) in Libya in 1981 and the Exports(as % of merchandise exports) in Sri Lanka in 1983?
Offer a terse response. -28.53. What is the difference between the Exports(as % of merchandise exports) in Spain in 1981 and the Exports(as % of merchandise exports) in Sri Lanka in 1983?
Provide a short and direct response. 41.44. What is the difference between the Exports(as % of merchandise exports) in Hungary in 1981 and the Exports(as % of merchandise exports) in Libya in 1984?
Offer a very short reply. 61.44. What is the difference between the Exports(as % of merchandise exports) of Hungary in 1981 and the Exports(as % of merchandise exports) of Spain in 1984?
Give a very brief answer. -6.19. What is the difference between the Exports(as % of merchandise exports) of Hungary in 1981 and the Exports(as % of merchandise exports) of Sri Lanka in 1984?
Provide a short and direct response. 36.41. What is the difference between the Exports(as % of merchandise exports) of Libya in 1981 and the Exports(as % of merchandise exports) of Spain in 1984?
Offer a very short reply. -68.83. What is the difference between the Exports(as % of merchandise exports) in Libya in 1981 and the Exports(as % of merchandise exports) in Sri Lanka in 1984?
Provide a succinct answer. -26.24. What is the difference between the Exports(as % of merchandise exports) in Spain in 1981 and the Exports(as % of merchandise exports) in Sri Lanka in 1984?
Make the answer very short. 43.73. What is the difference between the Exports(as % of merchandise exports) in Hungary in 1981 and the Exports(as % of merchandise exports) in Libya in 1985?
Your answer should be very brief. 61.55. What is the difference between the Exports(as % of merchandise exports) in Hungary in 1981 and the Exports(as % of merchandise exports) in Spain in 1985?
Give a very brief answer. -7.39. What is the difference between the Exports(as % of merchandise exports) in Hungary in 1981 and the Exports(as % of merchandise exports) in Sri Lanka in 1985?
Your answer should be compact. 30.41. What is the difference between the Exports(as % of merchandise exports) in Libya in 1981 and the Exports(as % of merchandise exports) in Spain in 1985?
Your answer should be compact. -70.04. What is the difference between the Exports(as % of merchandise exports) in Libya in 1981 and the Exports(as % of merchandise exports) in Sri Lanka in 1985?
Your answer should be very brief. -32.23. What is the difference between the Exports(as % of merchandise exports) of Spain in 1981 and the Exports(as % of merchandise exports) of Sri Lanka in 1985?
Provide a succinct answer. 37.73. What is the difference between the Exports(as % of merchandise exports) in Hungary in 1983 and the Exports(as % of merchandise exports) in Libya in 1984?
Your response must be concise. 59.34. What is the difference between the Exports(as % of merchandise exports) of Hungary in 1983 and the Exports(as % of merchandise exports) of Spain in 1984?
Ensure brevity in your answer.  -8.29. What is the difference between the Exports(as % of merchandise exports) in Hungary in 1983 and the Exports(as % of merchandise exports) in Sri Lanka in 1984?
Ensure brevity in your answer.  34.3. What is the difference between the Exports(as % of merchandise exports) of Libya in 1983 and the Exports(as % of merchandise exports) of Spain in 1984?
Keep it short and to the point. -68. What is the difference between the Exports(as % of merchandise exports) of Libya in 1983 and the Exports(as % of merchandise exports) of Sri Lanka in 1984?
Your answer should be compact. -25.41. What is the difference between the Exports(as % of merchandise exports) of Spain in 1983 and the Exports(as % of merchandise exports) of Sri Lanka in 1984?
Your answer should be compact. 43.08. What is the difference between the Exports(as % of merchandise exports) in Hungary in 1983 and the Exports(as % of merchandise exports) in Libya in 1985?
Keep it short and to the point. 59.45. What is the difference between the Exports(as % of merchandise exports) in Hungary in 1983 and the Exports(as % of merchandise exports) in Spain in 1985?
Offer a terse response. -9.5. What is the difference between the Exports(as % of merchandise exports) of Hungary in 1983 and the Exports(as % of merchandise exports) of Sri Lanka in 1985?
Your response must be concise. 28.31. What is the difference between the Exports(as % of merchandise exports) of Libya in 1983 and the Exports(as % of merchandise exports) of Spain in 1985?
Offer a very short reply. -69.21. What is the difference between the Exports(as % of merchandise exports) in Libya in 1983 and the Exports(as % of merchandise exports) in Sri Lanka in 1985?
Provide a short and direct response. -31.4. What is the difference between the Exports(as % of merchandise exports) of Spain in 1983 and the Exports(as % of merchandise exports) of Sri Lanka in 1985?
Ensure brevity in your answer.  37.08. What is the difference between the Exports(as % of merchandise exports) in Hungary in 1984 and the Exports(as % of merchandise exports) in Libya in 1985?
Provide a short and direct response. 60.43. What is the difference between the Exports(as % of merchandise exports) in Hungary in 1984 and the Exports(as % of merchandise exports) in Spain in 1985?
Your response must be concise. -8.52. What is the difference between the Exports(as % of merchandise exports) in Hungary in 1984 and the Exports(as % of merchandise exports) in Sri Lanka in 1985?
Your answer should be compact. 29.29. What is the difference between the Exports(as % of merchandise exports) in Libya in 1984 and the Exports(as % of merchandise exports) in Spain in 1985?
Offer a very short reply. -68.83. What is the difference between the Exports(as % of merchandise exports) of Libya in 1984 and the Exports(as % of merchandise exports) of Sri Lanka in 1985?
Provide a succinct answer. -31.03. What is the difference between the Exports(as % of merchandise exports) of Spain in 1984 and the Exports(as % of merchandise exports) of Sri Lanka in 1985?
Keep it short and to the point. 36.6. What is the average Exports(as % of merchandise exports) of Hungary per year?
Your answer should be very brief. 50.91. What is the average Exports(as % of merchandise exports) in Libya per year?
Provide a short and direct response. 0.67. What is the average Exports(as % of merchandise exports) of Spain per year?
Provide a short and direct response. 70.09. What is the average Exports(as % of merchandise exports) of Sri Lanka per year?
Offer a terse response. 17.77. In the year 1974, what is the difference between the Exports(as % of merchandise exports) of Hungary and Exports(as % of merchandise exports) of Libya?
Your answer should be very brief. 9.68. In the year 1974, what is the difference between the Exports(as % of merchandise exports) of Hungary and Exports(as % of merchandise exports) of Spain?
Offer a terse response. -54.94. In the year 1974, what is the difference between the Exports(as % of merchandise exports) of Hungary and Exports(as % of merchandise exports) of Sri Lanka?
Ensure brevity in your answer.  4.11. In the year 1974, what is the difference between the Exports(as % of merchandise exports) in Libya and Exports(as % of merchandise exports) in Spain?
Make the answer very short. -64.62. In the year 1974, what is the difference between the Exports(as % of merchandise exports) of Libya and Exports(as % of merchandise exports) of Sri Lanka?
Give a very brief answer. -5.57. In the year 1974, what is the difference between the Exports(as % of merchandise exports) of Spain and Exports(as % of merchandise exports) of Sri Lanka?
Provide a succinct answer. 59.06. In the year 1975, what is the difference between the Exports(as % of merchandise exports) of Hungary and Exports(as % of merchandise exports) of Libya?
Ensure brevity in your answer.  9.21. In the year 1975, what is the difference between the Exports(as % of merchandise exports) in Hungary and Exports(as % of merchandise exports) in Spain?
Your answer should be very brief. -60.79. In the year 1975, what is the difference between the Exports(as % of merchandise exports) of Hungary and Exports(as % of merchandise exports) of Sri Lanka?
Provide a succinct answer. 5.39. In the year 1975, what is the difference between the Exports(as % of merchandise exports) in Libya and Exports(as % of merchandise exports) in Spain?
Offer a terse response. -70. In the year 1975, what is the difference between the Exports(as % of merchandise exports) of Libya and Exports(as % of merchandise exports) of Sri Lanka?
Your answer should be compact. -3.82. In the year 1975, what is the difference between the Exports(as % of merchandise exports) of Spain and Exports(as % of merchandise exports) of Sri Lanka?
Provide a succinct answer. 66.18. In the year 1978, what is the difference between the Exports(as % of merchandise exports) in Hungary and Exports(as % of merchandise exports) in Libya?
Your answer should be very brief. 67.95. In the year 1978, what is the difference between the Exports(as % of merchandise exports) of Hungary and Exports(as % of merchandise exports) of Spain?
Provide a short and direct response. -5.03. In the year 1978, what is the difference between the Exports(as % of merchandise exports) of Hungary and Exports(as % of merchandise exports) of Sri Lanka?
Your answer should be very brief. 60.76. In the year 1978, what is the difference between the Exports(as % of merchandise exports) of Libya and Exports(as % of merchandise exports) of Spain?
Offer a terse response. -72.98. In the year 1978, what is the difference between the Exports(as % of merchandise exports) of Libya and Exports(as % of merchandise exports) of Sri Lanka?
Your response must be concise. -7.19. In the year 1978, what is the difference between the Exports(as % of merchandise exports) in Spain and Exports(as % of merchandise exports) in Sri Lanka?
Give a very brief answer. 65.79. In the year 1979, what is the difference between the Exports(as % of merchandise exports) of Hungary and Exports(as % of merchandise exports) of Libya?
Give a very brief answer. 67.15. In the year 1979, what is the difference between the Exports(as % of merchandise exports) in Hungary and Exports(as % of merchandise exports) in Spain?
Offer a very short reply. -5.65. In the year 1979, what is the difference between the Exports(as % of merchandise exports) in Hungary and Exports(as % of merchandise exports) in Sri Lanka?
Offer a very short reply. 51.95. In the year 1979, what is the difference between the Exports(as % of merchandise exports) in Libya and Exports(as % of merchandise exports) in Spain?
Make the answer very short. -72.8. In the year 1979, what is the difference between the Exports(as % of merchandise exports) of Libya and Exports(as % of merchandise exports) of Sri Lanka?
Ensure brevity in your answer.  -15.21. In the year 1979, what is the difference between the Exports(as % of merchandise exports) in Spain and Exports(as % of merchandise exports) in Sri Lanka?
Your answer should be very brief. 57.6. In the year 1981, what is the difference between the Exports(as % of merchandise exports) in Hungary and Exports(as % of merchandise exports) in Libya?
Your answer should be very brief. 62.65. In the year 1981, what is the difference between the Exports(as % of merchandise exports) of Hungary and Exports(as % of merchandise exports) of Spain?
Make the answer very short. -7.32. In the year 1981, what is the difference between the Exports(as % of merchandise exports) in Hungary and Exports(as % of merchandise exports) in Sri Lanka?
Offer a terse response. 41.47. In the year 1981, what is the difference between the Exports(as % of merchandise exports) of Libya and Exports(as % of merchandise exports) of Spain?
Offer a terse response. -69.97. In the year 1981, what is the difference between the Exports(as % of merchandise exports) of Libya and Exports(as % of merchandise exports) of Sri Lanka?
Provide a succinct answer. -21.17. In the year 1981, what is the difference between the Exports(as % of merchandise exports) in Spain and Exports(as % of merchandise exports) in Sri Lanka?
Offer a terse response. 48.79. In the year 1983, what is the difference between the Exports(as % of merchandise exports) of Hungary and Exports(as % of merchandise exports) of Libya?
Make the answer very short. 59.71. In the year 1983, what is the difference between the Exports(as % of merchandise exports) in Hungary and Exports(as % of merchandise exports) in Spain?
Make the answer very short. -8.77. In the year 1983, what is the difference between the Exports(as % of merchandise exports) of Hungary and Exports(as % of merchandise exports) of Sri Lanka?
Ensure brevity in your answer.  32.01. In the year 1983, what is the difference between the Exports(as % of merchandise exports) in Libya and Exports(as % of merchandise exports) in Spain?
Your answer should be compact. -68.48. In the year 1983, what is the difference between the Exports(as % of merchandise exports) of Libya and Exports(as % of merchandise exports) of Sri Lanka?
Offer a terse response. -27.7. In the year 1983, what is the difference between the Exports(as % of merchandise exports) in Spain and Exports(as % of merchandise exports) in Sri Lanka?
Your response must be concise. 40.79. In the year 1984, what is the difference between the Exports(as % of merchandise exports) in Hungary and Exports(as % of merchandise exports) in Libya?
Offer a very short reply. 60.32. In the year 1984, what is the difference between the Exports(as % of merchandise exports) of Hungary and Exports(as % of merchandise exports) of Spain?
Offer a terse response. -7.31. In the year 1984, what is the difference between the Exports(as % of merchandise exports) in Hungary and Exports(as % of merchandise exports) in Sri Lanka?
Provide a succinct answer. 35.28. In the year 1984, what is the difference between the Exports(as % of merchandise exports) in Libya and Exports(as % of merchandise exports) in Spain?
Ensure brevity in your answer.  -67.63. In the year 1984, what is the difference between the Exports(as % of merchandise exports) of Libya and Exports(as % of merchandise exports) of Sri Lanka?
Make the answer very short. -25.03. In the year 1984, what is the difference between the Exports(as % of merchandise exports) of Spain and Exports(as % of merchandise exports) of Sri Lanka?
Your answer should be compact. 42.59. In the year 1985, what is the difference between the Exports(as % of merchandise exports) of Hungary and Exports(as % of merchandise exports) of Libya?
Keep it short and to the point. 65.31. In the year 1985, what is the difference between the Exports(as % of merchandise exports) of Hungary and Exports(as % of merchandise exports) of Spain?
Make the answer very short. -3.64. In the year 1985, what is the difference between the Exports(as % of merchandise exports) in Hungary and Exports(as % of merchandise exports) in Sri Lanka?
Your answer should be compact. 34.17. In the year 1985, what is the difference between the Exports(as % of merchandise exports) in Libya and Exports(as % of merchandise exports) in Spain?
Provide a succinct answer. -68.95. In the year 1985, what is the difference between the Exports(as % of merchandise exports) of Libya and Exports(as % of merchandise exports) of Sri Lanka?
Make the answer very short. -31.14. In the year 1985, what is the difference between the Exports(as % of merchandise exports) in Spain and Exports(as % of merchandise exports) in Sri Lanka?
Give a very brief answer. 37.81. What is the ratio of the Exports(as % of merchandise exports) of Hungary in 1974 to that in 1975?
Make the answer very short. 1.05. What is the ratio of the Exports(as % of merchandise exports) of Libya in 1974 to that in 1975?
Ensure brevity in your answer.  32.11. What is the ratio of the Exports(as % of merchandise exports) of Spain in 1974 to that in 1975?
Offer a terse response. 0.92. What is the ratio of the Exports(as % of merchandise exports) of Sri Lanka in 1974 to that in 1975?
Ensure brevity in your answer.  1.46. What is the ratio of the Exports(as % of merchandise exports) in Hungary in 1974 to that in 1978?
Make the answer very short. 0.14. What is the ratio of the Exports(as % of merchandise exports) in Spain in 1974 to that in 1978?
Keep it short and to the point. 0.88. What is the ratio of the Exports(as % of merchandise exports) of Sri Lanka in 1974 to that in 1978?
Your answer should be compact. 0.75. What is the ratio of the Exports(as % of merchandise exports) of Hungary in 1974 to that in 1979?
Offer a terse response. 0.14. What is the ratio of the Exports(as % of merchandise exports) in Spain in 1974 to that in 1979?
Offer a terse response. 0.88. What is the ratio of the Exports(as % of merchandise exports) of Sri Lanka in 1974 to that in 1979?
Offer a very short reply. 0.36. What is the ratio of the Exports(as % of merchandise exports) of Hungary in 1974 to that in 1981?
Ensure brevity in your answer.  0.15. What is the ratio of the Exports(as % of merchandise exports) of Spain in 1974 to that in 1981?
Provide a succinct answer. 0.92. What is the ratio of the Exports(as % of merchandise exports) of Sri Lanka in 1974 to that in 1981?
Keep it short and to the point. 0.26. What is the ratio of the Exports(as % of merchandise exports) in Hungary in 1974 to that in 1983?
Provide a succinct answer. 0.16. What is the ratio of the Exports(as % of merchandise exports) in Spain in 1974 to that in 1983?
Provide a succinct answer. 0.93. What is the ratio of the Exports(as % of merchandise exports) in Sri Lanka in 1974 to that in 1983?
Your response must be concise. 0.19. What is the ratio of the Exports(as % of merchandise exports) of Hungary in 1974 to that in 1984?
Offer a terse response. 0.16. What is the ratio of the Exports(as % of merchandise exports) in Spain in 1974 to that in 1984?
Your answer should be very brief. 0.93. What is the ratio of the Exports(as % of merchandise exports) in Sri Lanka in 1974 to that in 1984?
Your response must be concise. 0.21. What is the ratio of the Exports(as % of merchandise exports) of Hungary in 1974 to that in 1985?
Your answer should be very brief. 0.14. What is the ratio of the Exports(as % of merchandise exports) in Libya in 1974 to that in 1985?
Your answer should be compact. 0. What is the ratio of the Exports(as % of merchandise exports) of Spain in 1974 to that in 1985?
Your answer should be very brief. 0.92. What is the ratio of the Exports(as % of merchandise exports) of Sri Lanka in 1974 to that in 1985?
Your answer should be compact. 0.17. What is the ratio of the Exports(as % of merchandise exports) of Hungary in 1975 to that in 1978?
Give a very brief answer. 0.14. What is the ratio of the Exports(as % of merchandise exports) in Spain in 1975 to that in 1978?
Your answer should be compact. 0.96. What is the ratio of the Exports(as % of merchandise exports) of Sri Lanka in 1975 to that in 1978?
Offer a very short reply. 0.51. What is the ratio of the Exports(as % of merchandise exports) in Hungary in 1975 to that in 1979?
Keep it short and to the point. 0.14. What is the ratio of the Exports(as % of merchandise exports) of Libya in 1975 to that in 1979?
Offer a very short reply. 0. What is the ratio of the Exports(as % of merchandise exports) in Spain in 1975 to that in 1979?
Make the answer very short. 0.96. What is the ratio of the Exports(as % of merchandise exports) in Sri Lanka in 1975 to that in 1979?
Your answer should be very brief. 0.24. What is the ratio of the Exports(as % of merchandise exports) of Hungary in 1975 to that in 1981?
Provide a short and direct response. 0.15. What is the ratio of the Exports(as % of merchandise exports) in Spain in 1975 to that in 1981?
Your answer should be compact. 1. What is the ratio of the Exports(as % of merchandise exports) in Sri Lanka in 1975 to that in 1981?
Offer a very short reply. 0.18. What is the ratio of the Exports(as % of merchandise exports) in Hungary in 1975 to that in 1983?
Your answer should be compact. 0.15. What is the ratio of the Exports(as % of merchandise exports) in Libya in 1975 to that in 1983?
Provide a short and direct response. 0. What is the ratio of the Exports(as % of merchandise exports) of Spain in 1975 to that in 1983?
Provide a short and direct response. 1. What is the ratio of the Exports(as % of merchandise exports) of Sri Lanka in 1975 to that in 1983?
Ensure brevity in your answer.  0.13. What is the ratio of the Exports(as % of merchandise exports) of Hungary in 1975 to that in 1984?
Give a very brief answer. 0.15. What is the ratio of the Exports(as % of merchandise exports) in Spain in 1975 to that in 1984?
Offer a terse response. 1.01. What is the ratio of the Exports(as % of merchandise exports) of Sri Lanka in 1975 to that in 1984?
Offer a very short reply. 0.14. What is the ratio of the Exports(as % of merchandise exports) of Hungary in 1975 to that in 1985?
Offer a very short reply. 0.14. What is the ratio of the Exports(as % of merchandise exports) in Spain in 1975 to that in 1985?
Offer a very short reply. 0.99. What is the ratio of the Exports(as % of merchandise exports) in Sri Lanka in 1975 to that in 1985?
Give a very brief answer. 0.12. What is the ratio of the Exports(as % of merchandise exports) of Hungary in 1978 to that in 1979?
Offer a very short reply. 1.01. What is the ratio of the Exports(as % of merchandise exports) of Libya in 1978 to that in 1979?
Ensure brevity in your answer.  0.65. What is the ratio of the Exports(as % of merchandise exports) of Sri Lanka in 1978 to that in 1979?
Your response must be concise. 0.48. What is the ratio of the Exports(as % of merchandise exports) of Hungary in 1978 to that in 1981?
Make the answer very short. 1.08. What is the ratio of the Exports(as % of merchandise exports) in Libya in 1978 to that in 1981?
Your answer should be very brief. 0.75. What is the ratio of the Exports(as % of merchandise exports) of Spain in 1978 to that in 1981?
Offer a terse response. 1.04. What is the ratio of the Exports(as % of merchandise exports) in Sri Lanka in 1978 to that in 1981?
Provide a short and direct response. 0.35. What is the ratio of the Exports(as % of merchandise exports) of Hungary in 1978 to that in 1983?
Offer a terse response. 1.12. What is the ratio of the Exports(as % of merchandise exports) of Libya in 1978 to that in 1983?
Keep it short and to the point. 0.23. What is the ratio of the Exports(as % of merchandise exports) of Spain in 1978 to that in 1983?
Keep it short and to the point. 1.05. What is the ratio of the Exports(as % of merchandise exports) of Sri Lanka in 1978 to that in 1983?
Offer a terse response. 0.26. What is the ratio of the Exports(as % of merchandise exports) in Hungary in 1978 to that in 1984?
Offer a terse response. 1.1. What is the ratio of the Exports(as % of merchandise exports) in Libya in 1978 to that in 1984?
Keep it short and to the point. 0.18. What is the ratio of the Exports(as % of merchandise exports) of Spain in 1978 to that in 1984?
Keep it short and to the point. 1.06. What is the ratio of the Exports(as % of merchandise exports) in Sri Lanka in 1978 to that in 1984?
Keep it short and to the point. 0.28. What is the ratio of the Exports(as % of merchandise exports) of Hungary in 1978 to that in 1985?
Your answer should be compact. 1.02. What is the ratio of the Exports(as % of merchandise exports) in Libya in 1978 to that in 1985?
Offer a terse response. 0.19. What is the ratio of the Exports(as % of merchandise exports) in Spain in 1978 to that in 1985?
Provide a succinct answer. 1.04. What is the ratio of the Exports(as % of merchandise exports) of Sri Lanka in 1978 to that in 1985?
Your answer should be very brief. 0.23. What is the ratio of the Exports(as % of merchandise exports) in Hungary in 1979 to that in 1981?
Your response must be concise. 1.07. What is the ratio of the Exports(as % of merchandise exports) of Libya in 1979 to that in 1981?
Your answer should be very brief. 1.16. What is the ratio of the Exports(as % of merchandise exports) of Spain in 1979 to that in 1981?
Keep it short and to the point. 1.04. What is the ratio of the Exports(as % of merchandise exports) in Sri Lanka in 1979 to that in 1981?
Provide a succinct answer. 0.73. What is the ratio of the Exports(as % of merchandise exports) in Hungary in 1979 to that in 1983?
Your answer should be very brief. 1.11. What is the ratio of the Exports(as % of merchandise exports) of Libya in 1979 to that in 1983?
Ensure brevity in your answer.  0.36. What is the ratio of the Exports(as % of merchandise exports) in Spain in 1979 to that in 1983?
Provide a succinct answer. 1.05. What is the ratio of the Exports(as % of merchandise exports) of Sri Lanka in 1979 to that in 1983?
Provide a succinct answer. 0.54. What is the ratio of the Exports(as % of merchandise exports) of Hungary in 1979 to that in 1984?
Offer a very short reply. 1.09. What is the ratio of the Exports(as % of merchandise exports) in Libya in 1979 to that in 1984?
Make the answer very short. 0.27. What is the ratio of the Exports(as % of merchandise exports) in Spain in 1979 to that in 1984?
Ensure brevity in your answer.  1.06. What is the ratio of the Exports(as % of merchandise exports) of Sri Lanka in 1979 to that in 1984?
Ensure brevity in your answer.  0.59. What is the ratio of the Exports(as % of merchandise exports) in Hungary in 1979 to that in 1985?
Your response must be concise. 1.01. What is the ratio of the Exports(as % of merchandise exports) of Libya in 1979 to that in 1985?
Keep it short and to the point. 0.29. What is the ratio of the Exports(as % of merchandise exports) in Spain in 1979 to that in 1985?
Your answer should be very brief. 1.04. What is the ratio of the Exports(as % of merchandise exports) in Sri Lanka in 1979 to that in 1985?
Your answer should be compact. 0.48. What is the ratio of the Exports(as % of merchandise exports) of Hungary in 1981 to that in 1983?
Your response must be concise. 1.03. What is the ratio of the Exports(as % of merchandise exports) of Libya in 1981 to that in 1983?
Provide a short and direct response. 0.31. What is the ratio of the Exports(as % of merchandise exports) in Spain in 1981 to that in 1983?
Keep it short and to the point. 1.01. What is the ratio of the Exports(as % of merchandise exports) of Sri Lanka in 1981 to that in 1983?
Your response must be concise. 0.75. What is the ratio of the Exports(as % of merchandise exports) of Hungary in 1981 to that in 1984?
Your answer should be compact. 1.02. What is the ratio of the Exports(as % of merchandise exports) in Libya in 1981 to that in 1984?
Keep it short and to the point. 0.24. What is the ratio of the Exports(as % of merchandise exports) in Spain in 1981 to that in 1984?
Ensure brevity in your answer.  1.02. What is the ratio of the Exports(as % of merchandise exports) of Sri Lanka in 1981 to that in 1984?
Offer a very short reply. 0.81. What is the ratio of the Exports(as % of merchandise exports) in Hungary in 1981 to that in 1985?
Keep it short and to the point. 0.94. What is the ratio of the Exports(as % of merchandise exports) of Libya in 1981 to that in 1985?
Give a very brief answer. 0.25. What is the ratio of the Exports(as % of merchandise exports) of Spain in 1981 to that in 1985?
Give a very brief answer. 1. What is the ratio of the Exports(as % of merchandise exports) in Sri Lanka in 1981 to that in 1985?
Give a very brief answer. 0.66. What is the ratio of the Exports(as % of merchandise exports) of Hungary in 1983 to that in 1984?
Make the answer very short. 0.98. What is the ratio of the Exports(as % of merchandise exports) of Libya in 1983 to that in 1984?
Make the answer very short. 0.76. What is the ratio of the Exports(as % of merchandise exports) of Sri Lanka in 1983 to that in 1984?
Make the answer very short. 1.09. What is the ratio of the Exports(as % of merchandise exports) in Hungary in 1983 to that in 1985?
Offer a terse response. 0.91. What is the ratio of the Exports(as % of merchandise exports) in Libya in 1983 to that in 1985?
Ensure brevity in your answer.  0.82. What is the ratio of the Exports(as % of merchandise exports) of Sri Lanka in 1983 to that in 1985?
Offer a terse response. 0.89. What is the ratio of the Exports(as % of merchandise exports) in Hungary in 1984 to that in 1985?
Provide a succinct answer. 0.93. What is the ratio of the Exports(as % of merchandise exports) of Libya in 1984 to that in 1985?
Your answer should be compact. 1.08. What is the ratio of the Exports(as % of merchandise exports) in Spain in 1984 to that in 1985?
Your response must be concise. 0.98. What is the ratio of the Exports(as % of merchandise exports) of Sri Lanka in 1984 to that in 1985?
Your answer should be very brief. 0.82. What is the difference between the highest and the second highest Exports(as % of merchandise exports) in Hungary?
Make the answer very short. 0.64. What is the difference between the highest and the second highest Exports(as % of merchandise exports) in Libya?
Your answer should be compact. 0.11. What is the difference between the highest and the second highest Exports(as % of merchandise exports) of Spain?
Provide a short and direct response. 0.02. What is the difference between the highest and the second highest Exports(as % of merchandise exports) of Sri Lanka?
Your answer should be compact. 3.7. What is the difference between the highest and the lowest Exports(as % of merchandise exports) in Hungary?
Your answer should be compact. 59.02. What is the difference between the highest and the lowest Exports(as % of merchandise exports) of Libya?
Make the answer very short. 1.58. What is the difference between the highest and the lowest Exports(as % of merchandise exports) of Spain?
Offer a terse response. 8.64. What is the difference between the highest and the lowest Exports(as % of merchandise exports) of Sri Lanka?
Ensure brevity in your answer.  28.78. 